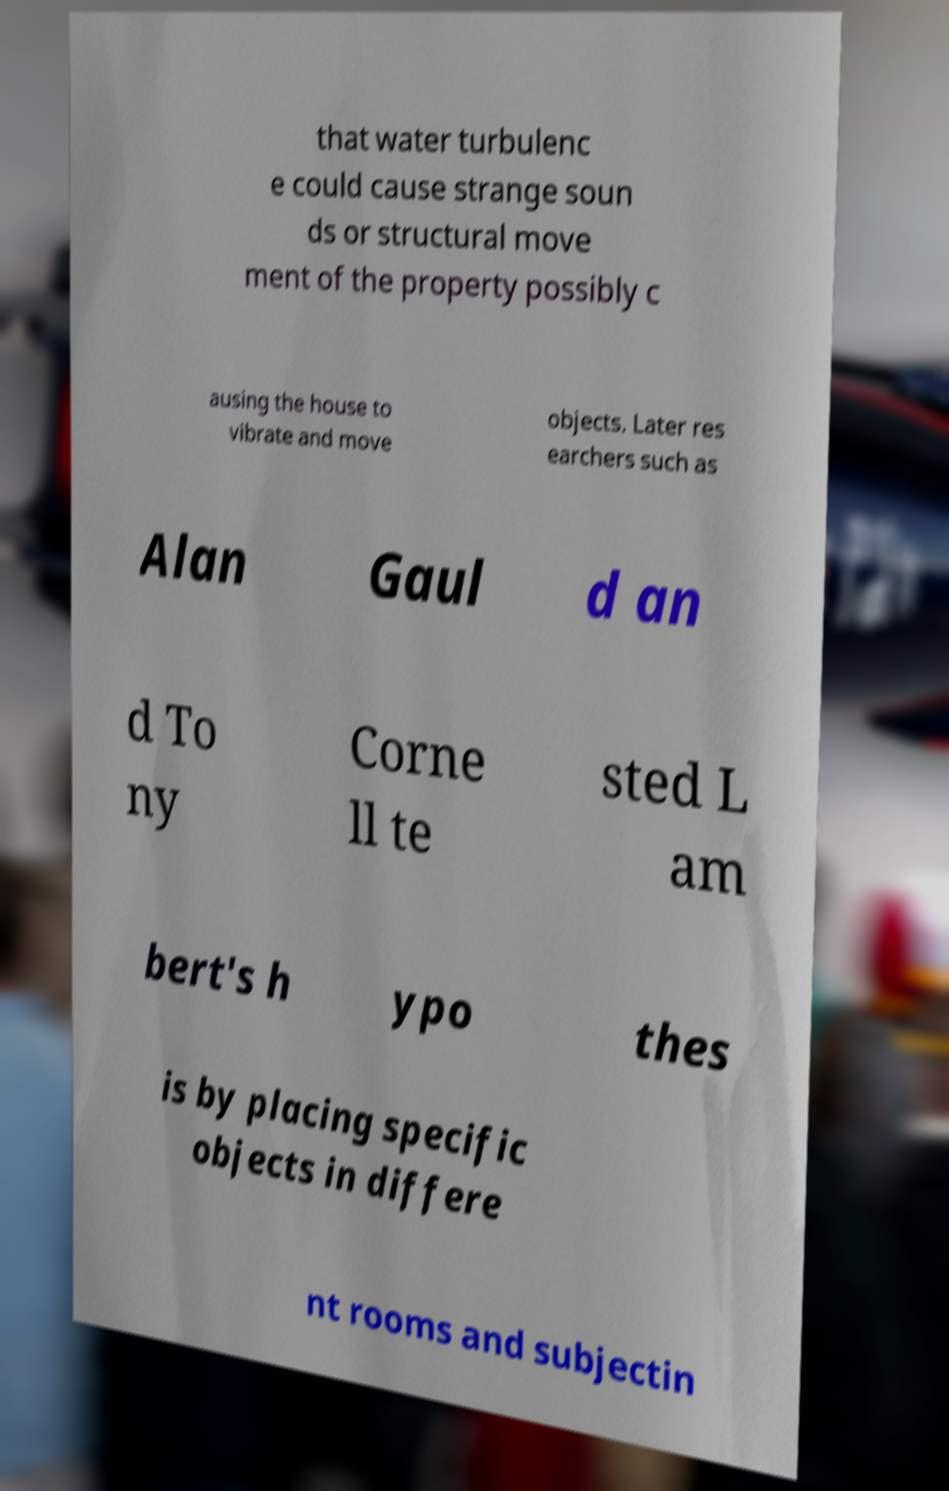Please identify and transcribe the text found in this image. that water turbulenc e could cause strange soun ds or structural move ment of the property possibly c ausing the house to vibrate and move objects. Later res earchers such as Alan Gaul d an d To ny Corne ll te sted L am bert's h ypo thes is by placing specific objects in differe nt rooms and subjectin 